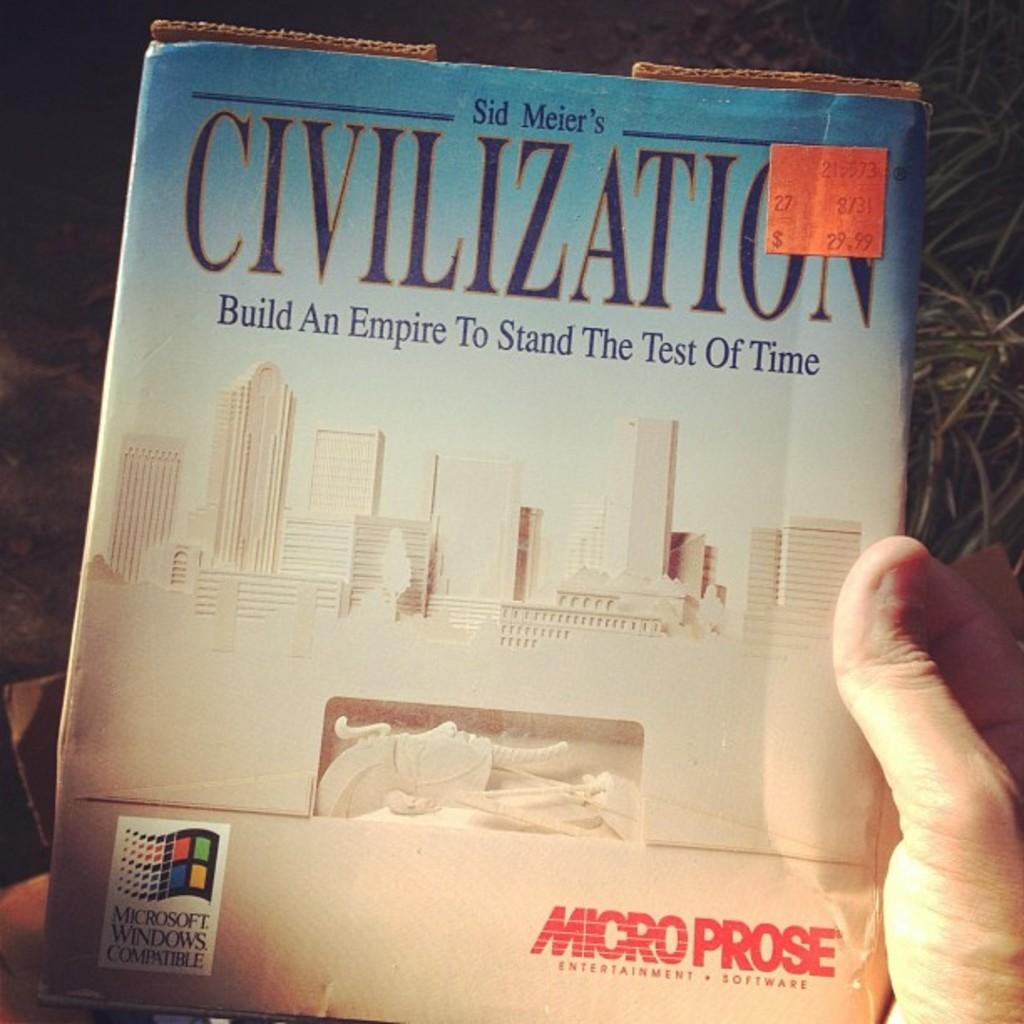Provide a one-sentence caption for the provided image. Someone holds a book cover for Civilization by Sid Meier. 